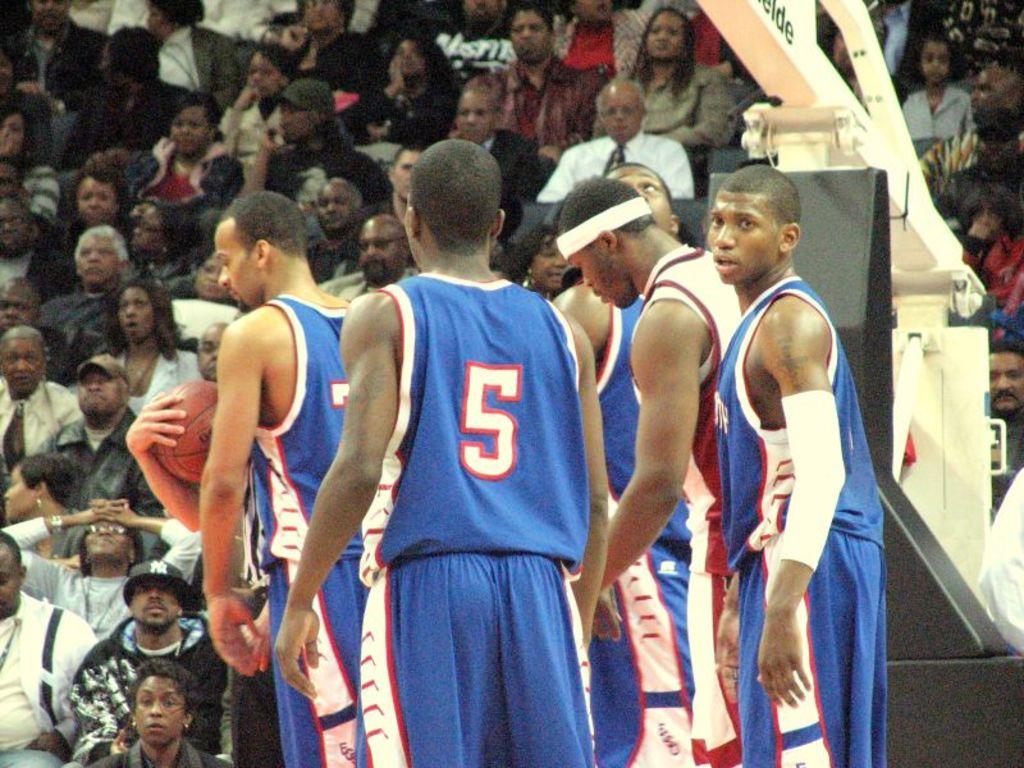What is the number on the jersey of the player with his back to you?
Offer a very short reply. 5. 